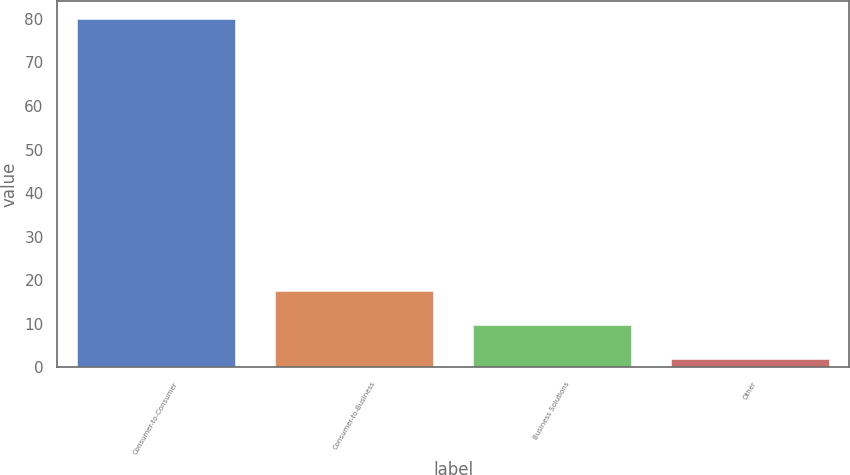Convert chart to OTSL. <chart><loc_0><loc_0><loc_500><loc_500><bar_chart><fcel>Consumer-to-Consumer<fcel>Consumer-to-Business<fcel>Business Solutions<fcel>Other<nl><fcel>80<fcel>17.6<fcel>9.8<fcel>2<nl></chart> 